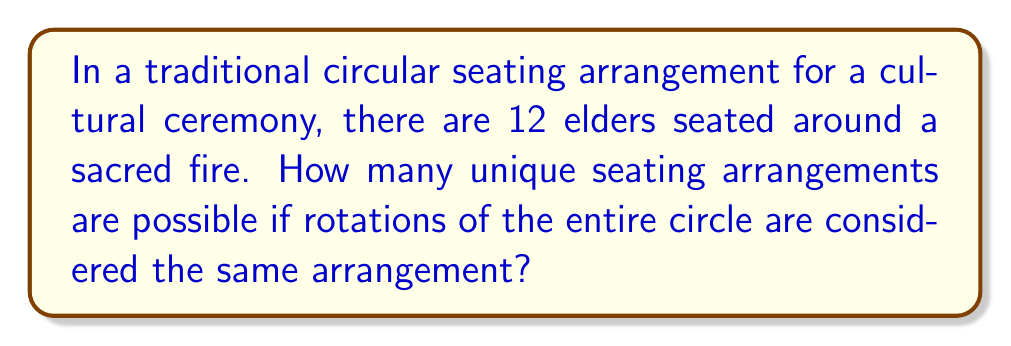Help me with this question. To solve this problem, we need to use concepts from group theory, specifically the orbit-stabilizer theorem and cyclic groups.

1) First, let's consider the total number of permutations of 12 people. This would be 12! (12 factorial).

2) However, in this case, rotations of the entire circle are considered the same arrangement. This means we're dealing with a cyclic group of order 12, denoted as $C_{12}$.

3) The orbit-stabilizer theorem states that for a group $G$ acting on a set $X$, the number of elements in the orbit of an element $x \in X$ is equal to the index of the stabilizer of $x$ in $G$:

   $|Orb(x)| = \frac{|G|}{|Stab(x)|}$

4) In our case, $G$ is the symmetric group $S_{12}$, and $Stab(x)$ is $C_{12}$ (because rotations leave the arrangement unchanged).

5) Therefore, the number of unique arrangements is:

   $\frac{|S_{12}|}{|C_{12}|} = \frac{12!}{12} = (11)!$

6) We can calculate this:
   
   $(11)! = 39,916,800$

This represents the number of ways to arrange 11 people in a line (since the 12th person's position is fixed once the other 11 are arranged), which is equivalent to our circular arrangement problem.
Answer: $39,916,800$ 